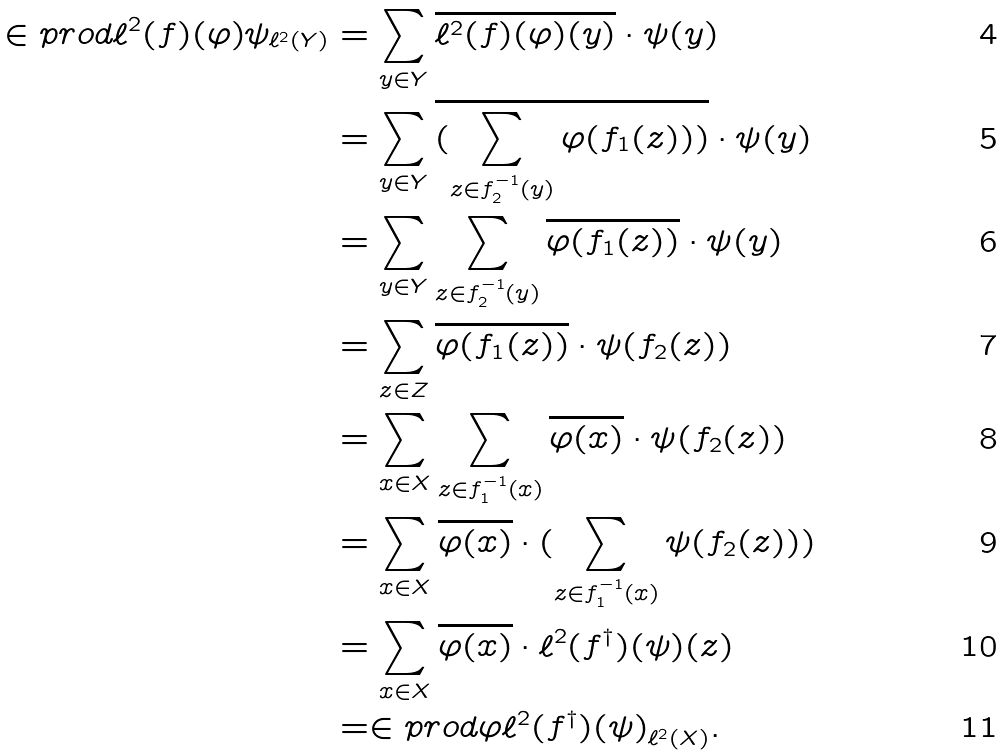Convert formula to latex. <formula><loc_0><loc_0><loc_500><loc_500>\in p r o d { \ell ^ { 2 } ( f ) ( \varphi ) } { \psi } _ { \ell ^ { 2 } ( Y ) } & = \sum _ { y \in Y } \overline { \ell ^ { 2 } ( f ) ( \varphi ) ( y ) } \cdot \psi ( y ) \\ & = \sum _ { y \in Y } \overline { ( \sum _ { z \in f _ { 2 } ^ { - 1 } ( y ) } \varphi ( f _ { 1 } ( z ) ) ) } \cdot \psi ( y ) \\ & = \sum _ { y \in Y } \sum _ { z \in f _ { 2 } ^ { - 1 } ( y ) } \overline { \varphi ( f _ { 1 } ( z ) ) } \cdot \psi ( y ) \\ & = \sum _ { z \in Z } \overline { \varphi ( f _ { 1 } ( z ) ) } \cdot \psi ( f _ { 2 } ( z ) ) \\ & = \sum _ { x \in X } \sum _ { z \in f _ { 1 } ^ { - 1 } ( x ) } \overline { \varphi ( x ) } \cdot \psi ( f _ { 2 } ( z ) ) \\ & = \sum _ { x \in X } \overline { \varphi ( x ) } \cdot ( \sum _ { z \in f _ { 1 } ^ { - 1 } ( x ) } \psi ( f _ { 2 } ( z ) ) ) \\ & = \sum _ { x \in X } \overline { \varphi ( x ) } \cdot \ell ^ { 2 } ( f ^ { \dag } ) ( \psi ) ( z ) \\ & = \in p r o d { \varphi } { \ell ^ { 2 } ( f ^ { \dag } ) ( \psi ) } _ { \ell ^ { 2 } ( X ) } .</formula> 